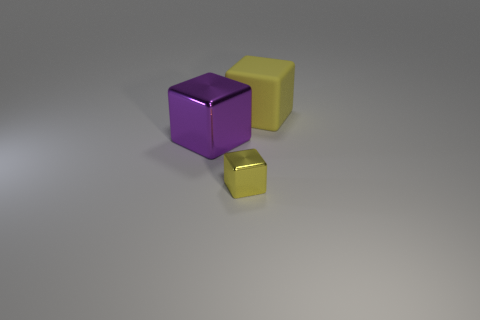What material is the large yellow thing?
Your answer should be very brief. Rubber. How many other things are the same size as the purple object?
Offer a terse response. 1. There is a shiny object that is in front of the big metallic thing; what size is it?
Make the answer very short. Small. What is the material of the yellow thing that is behind the metal object on the left side of the small shiny cube in front of the purple thing?
Your response must be concise. Rubber. Do the large purple metallic thing and the yellow rubber object have the same shape?
Keep it short and to the point. Yes. What number of metal objects are either big cubes or yellow objects?
Your answer should be compact. 2. What number of big metallic balls are there?
Give a very brief answer. 0. What color is the object that is the same size as the purple metallic cube?
Ensure brevity in your answer.  Yellow. Does the rubber thing have the same size as the yellow metal object?
Provide a short and direct response. No. There is a big thing that is the same color as the tiny metallic block; what is its shape?
Ensure brevity in your answer.  Cube. 